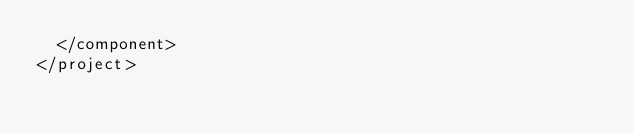<code> <loc_0><loc_0><loc_500><loc_500><_XML_>  </component>
</project></code> 